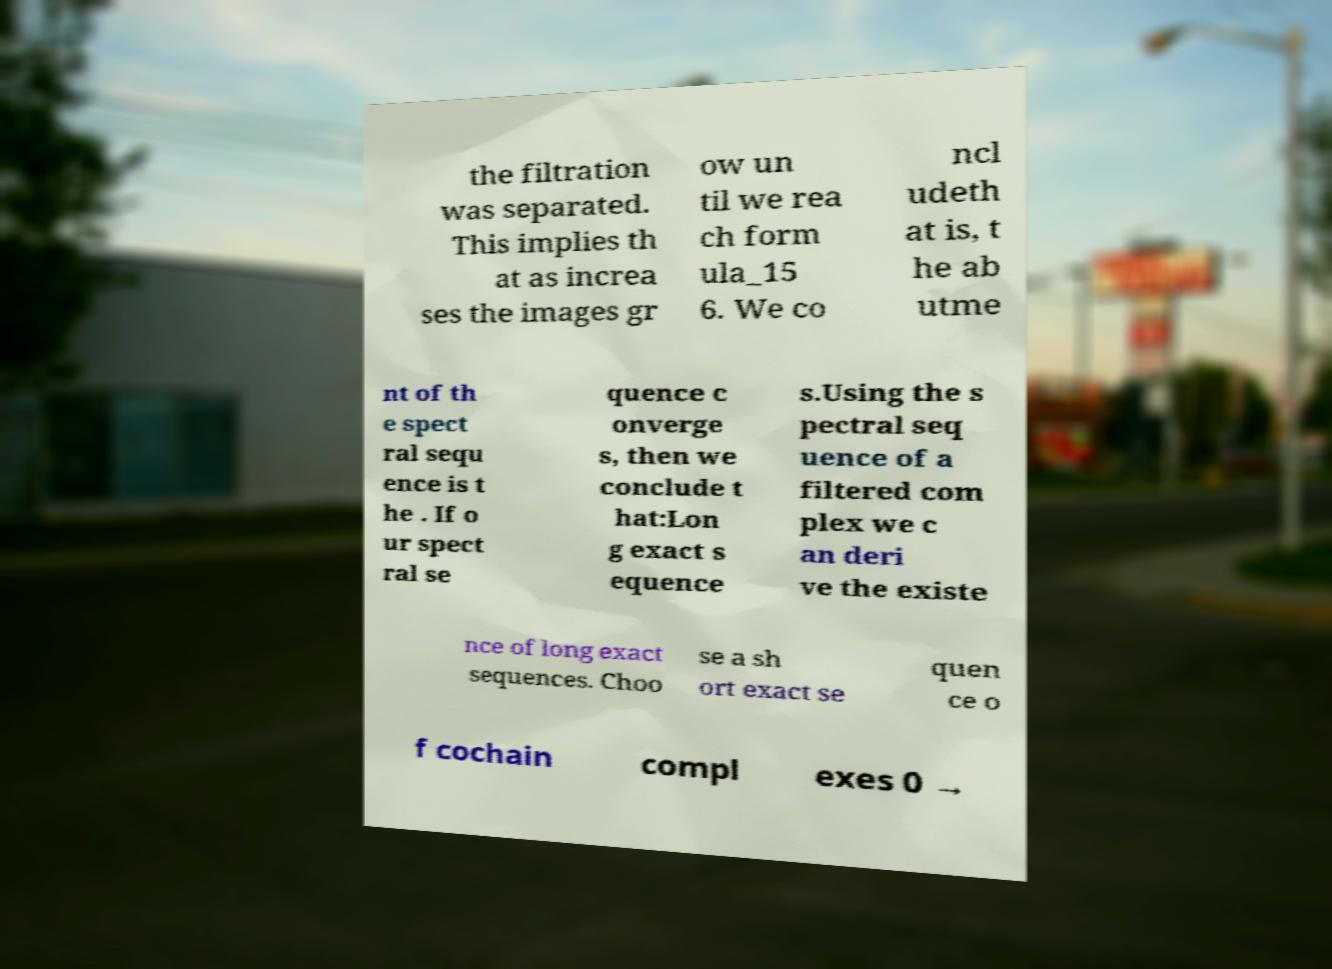What messages or text are displayed in this image? I need them in a readable, typed format. the filtration was separated. This implies th at as increa ses the images gr ow un til we rea ch form ula_15 6. We co ncl udeth at is, t he ab utme nt of th e spect ral sequ ence is t he . If o ur spect ral se quence c onverge s, then we conclude t hat:Lon g exact s equence s.Using the s pectral seq uence of a filtered com plex we c an deri ve the existe nce of long exact sequences. Choo se a sh ort exact se quen ce o f cochain compl exes 0 → 